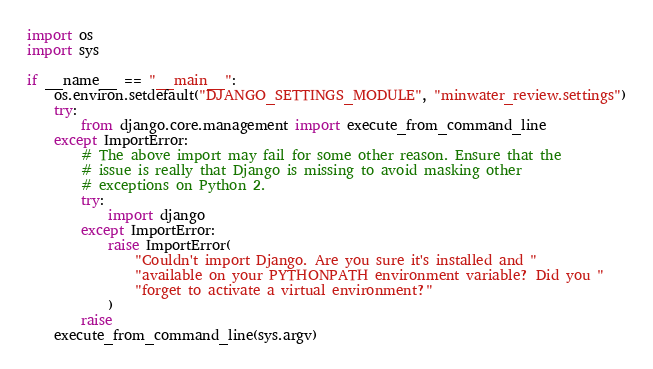Convert code to text. <code><loc_0><loc_0><loc_500><loc_500><_Python_>import os
import sys

if __name__ == "__main__":
    os.environ.setdefault("DJANGO_SETTINGS_MODULE", "minwater_review.settings")
    try:
        from django.core.management import execute_from_command_line
    except ImportError:
        # The above import may fail for some other reason. Ensure that the
        # issue is really that Django is missing to avoid masking other
        # exceptions on Python 2.
        try:
            import django
        except ImportError:
            raise ImportError(
                "Couldn't import Django. Are you sure it's installed and "
                "available on your PYTHONPATH environment variable? Did you "
                "forget to activate a virtual environment?"
            )
        raise
    execute_from_command_line(sys.argv)
</code> 